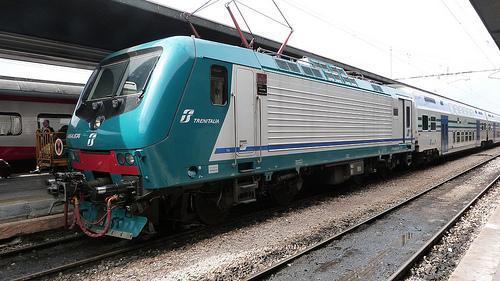How many trains are visible?
Give a very brief answer. 2. 